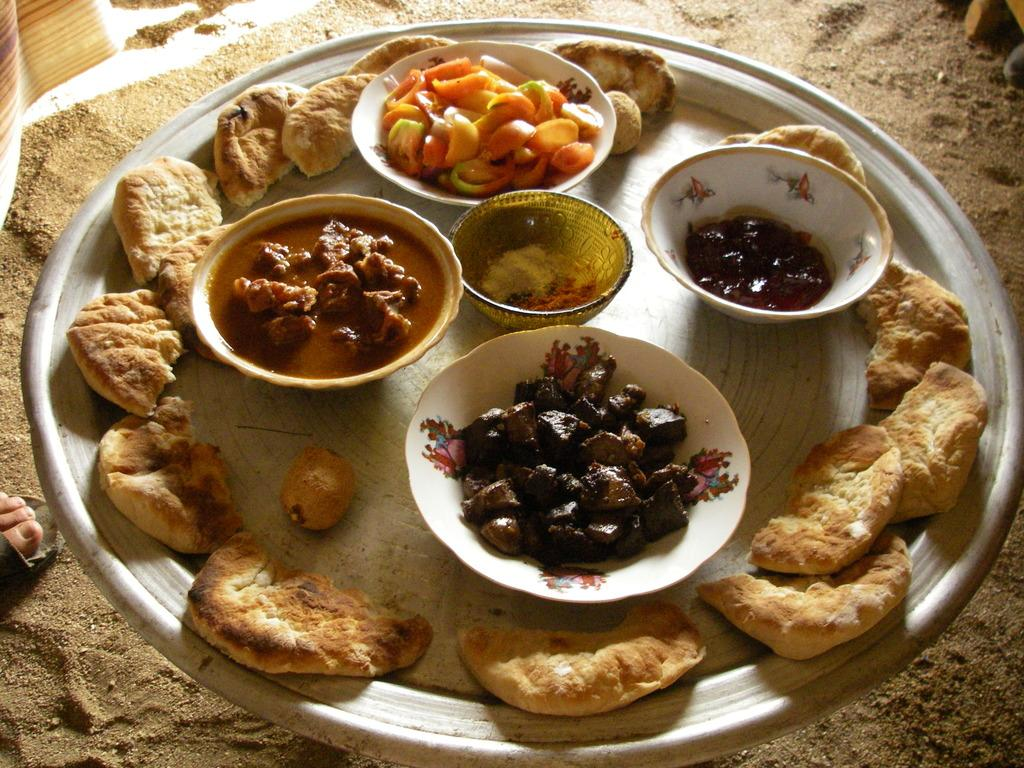What is on the plate that is visible in the image? There is a plate with food items in the image. Where are the bowls located in the image? The bowls are on the ground in the image. What type of badge can be seen on the plate in the image? There is no badge present on the plate in the image; it contains food items. In which direction is the railway located in the image? There is no railway present in the image. 